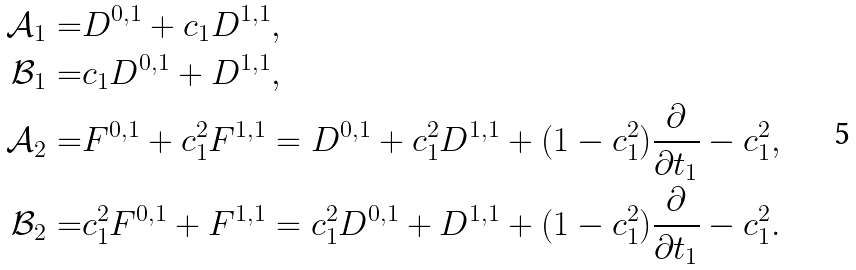Convert formula to latex. <formula><loc_0><loc_0><loc_500><loc_500>\mathcal { A } _ { 1 } = & D ^ { 0 , 1 } + c _ { 1 } D ^ { 1 , 1 } , \\ \mathcal { B } _ { 1 } = & c _ { 1 } D ^ { 0 , 1 } + D ^ { 1 , 1 } , \\ \mathcal { A } _ { 2 } = & F ^ { 0 , 1 } + c ^ { 2 } _ { 1 } F ^ { 1 , 1 } = D ^ { 0 , 1 } + c ^ { 2 } _ { 1 } D ^ { 1 , 1 } + ( 1 - c ^ { 2 } _ { 1 } ) \frac { \partial } { \partial t _ { 1 } } - c ^ { 2 } _ { 1 } , \\ \mathcal { B } _ { 2 } = & c ^ { 2 } _ { 1 } F ^ { 0 , 1 } + F ^ { 1 , 1 } = c ^ { 2 } _ { 1 } D ^ { 0 , 1 } + D ^ { 1 , 1 } + ( 1 - c ^ { 2 } _ { 1 } ) \frac { \partial } { \partial t _ { 1 } } - c ^ { 2 } _ { 1 } .</formula> 